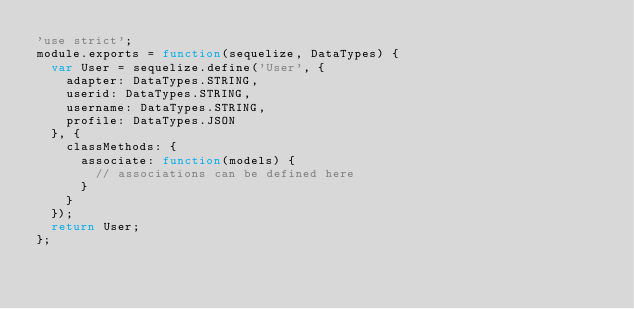<code> <loc_0><loc_0><loc_500><loc_500><_JavaScript_>'use strict';
module.exports = function(sequelize, DataTypes) {
  var User = sequelize.define('User', {
    adapter: DataTypes.STRING,
    userid: DataTypes.STRING,
    username: DataTypes.STRING,
    profile: DataTypes.JSON
  }, {
    classMethods: {
      associate: function(models) {
        // associations can be defined here
      }
    }
  });
  return User;
};</code> 